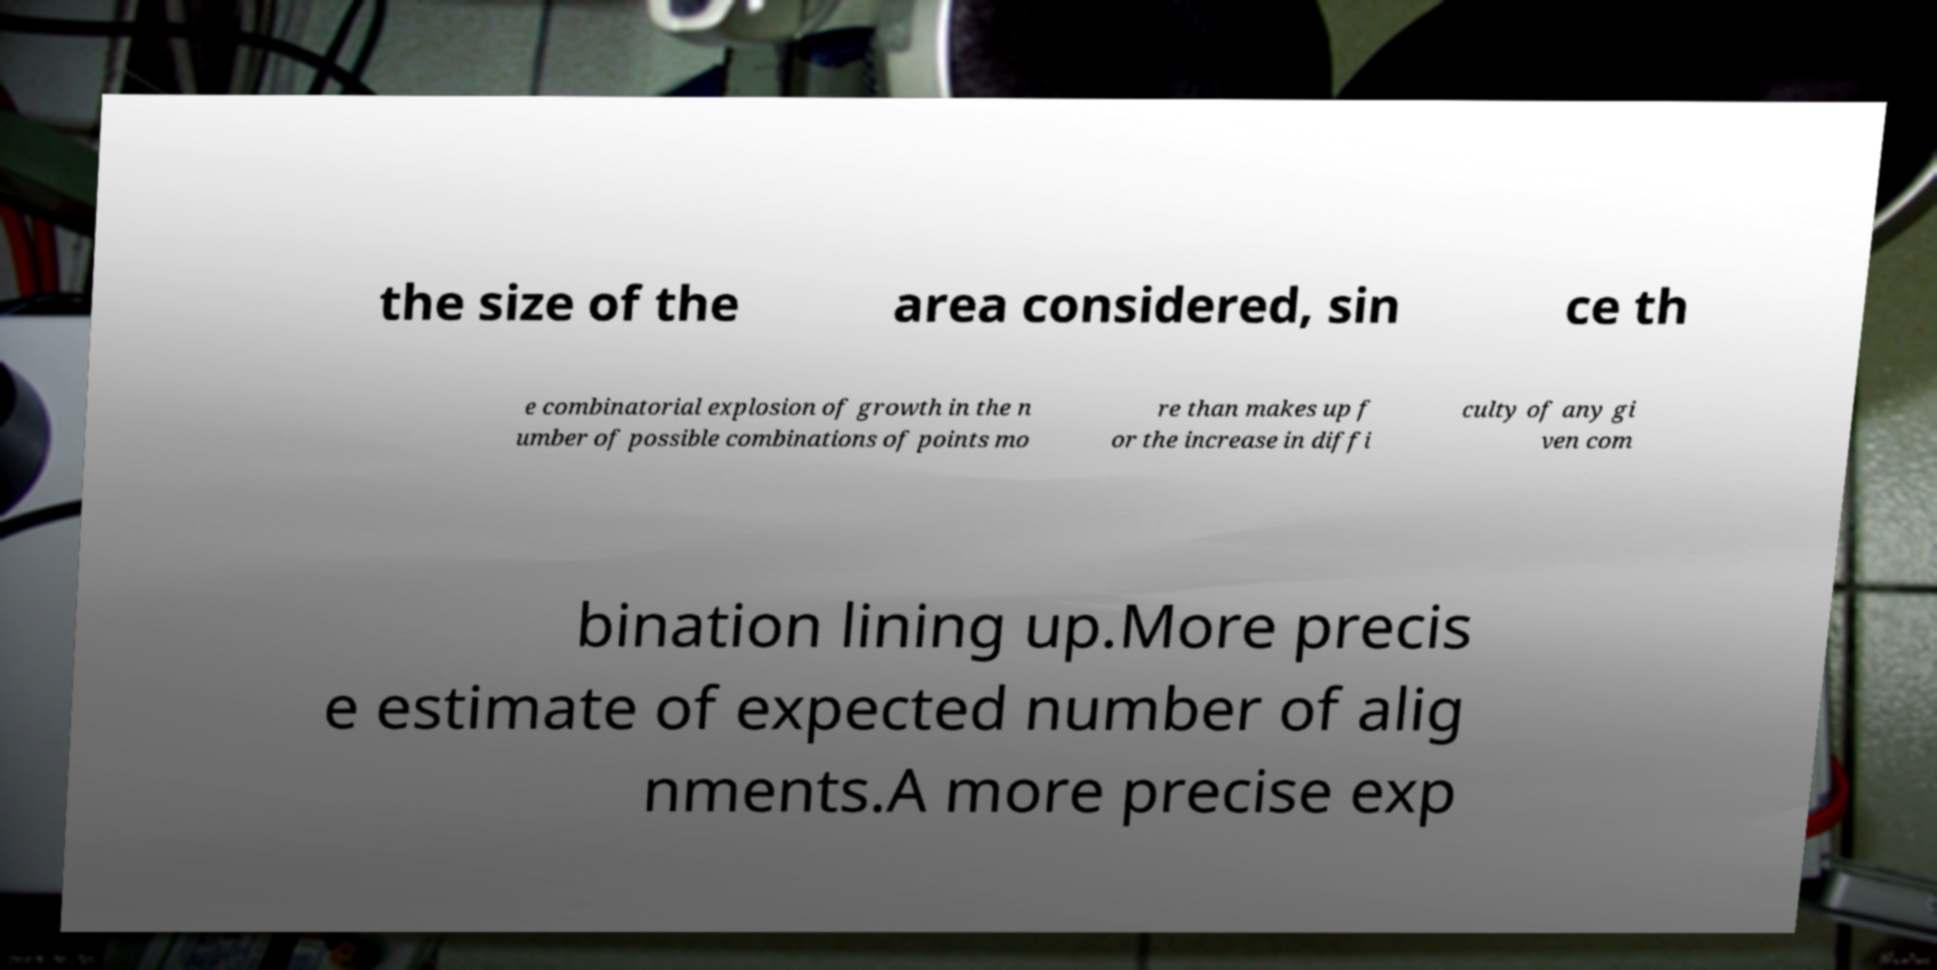I need the written content from this picture converted into text. Can you do that? the size of the area considered, sin ce th e combinatorial explosion of growth in the n umber of possible combinations of points mo re than makes up f or the increase in diffi culty of any gi ven com bination lining up.More precis e estimate of expected number of alig nments.A more precise exp 